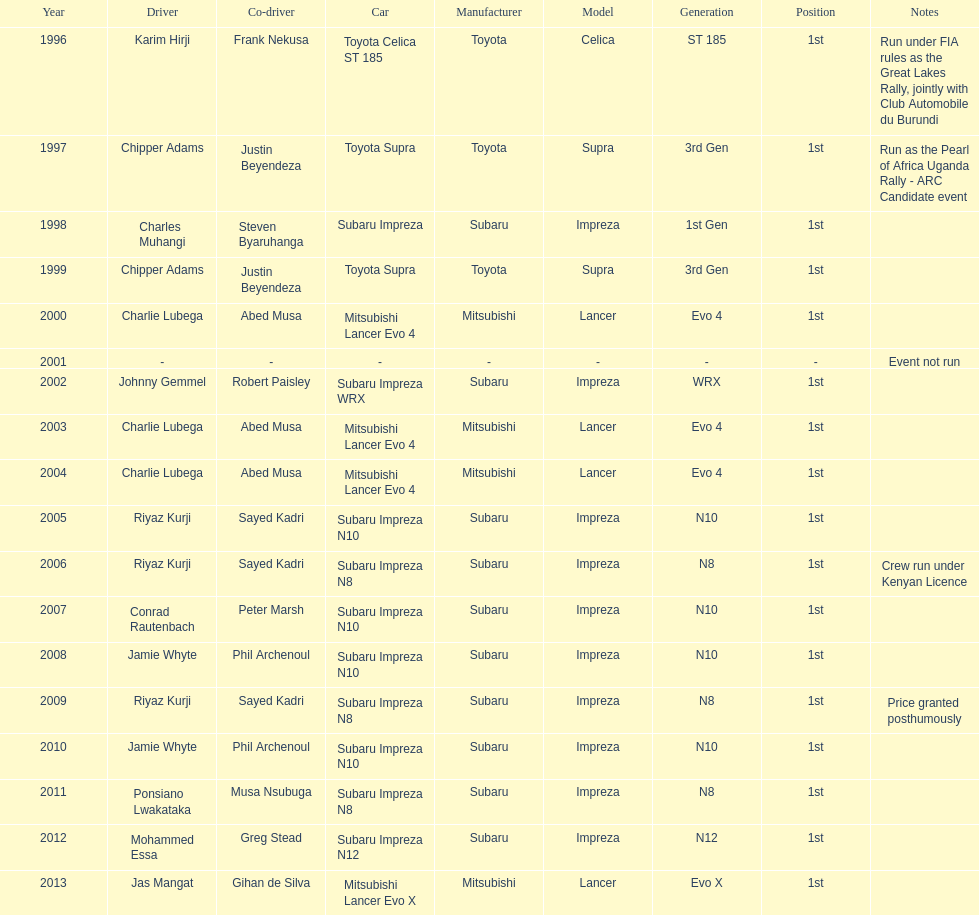Which driver won after ponsiano lwakataka? Mohammed Essa. 